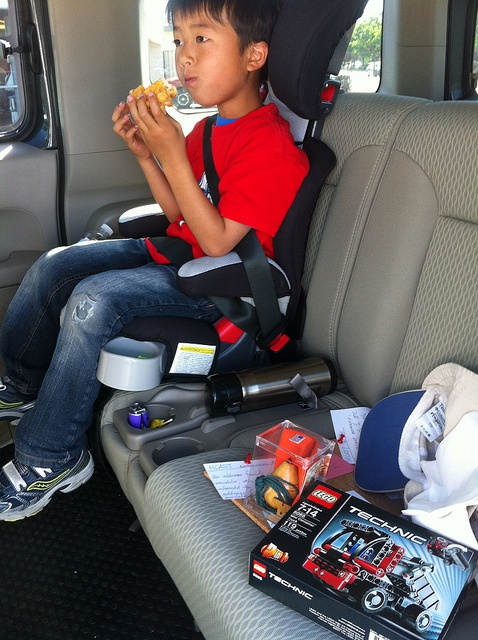Describe the objects in this image and their specific colors. I can see people in ivory, black, red, navy, and salmon tones, donut in ivory, orange, gold, and tan tones, and car in ivory, darkgray, lightgray, gray, and black tones in this image. 